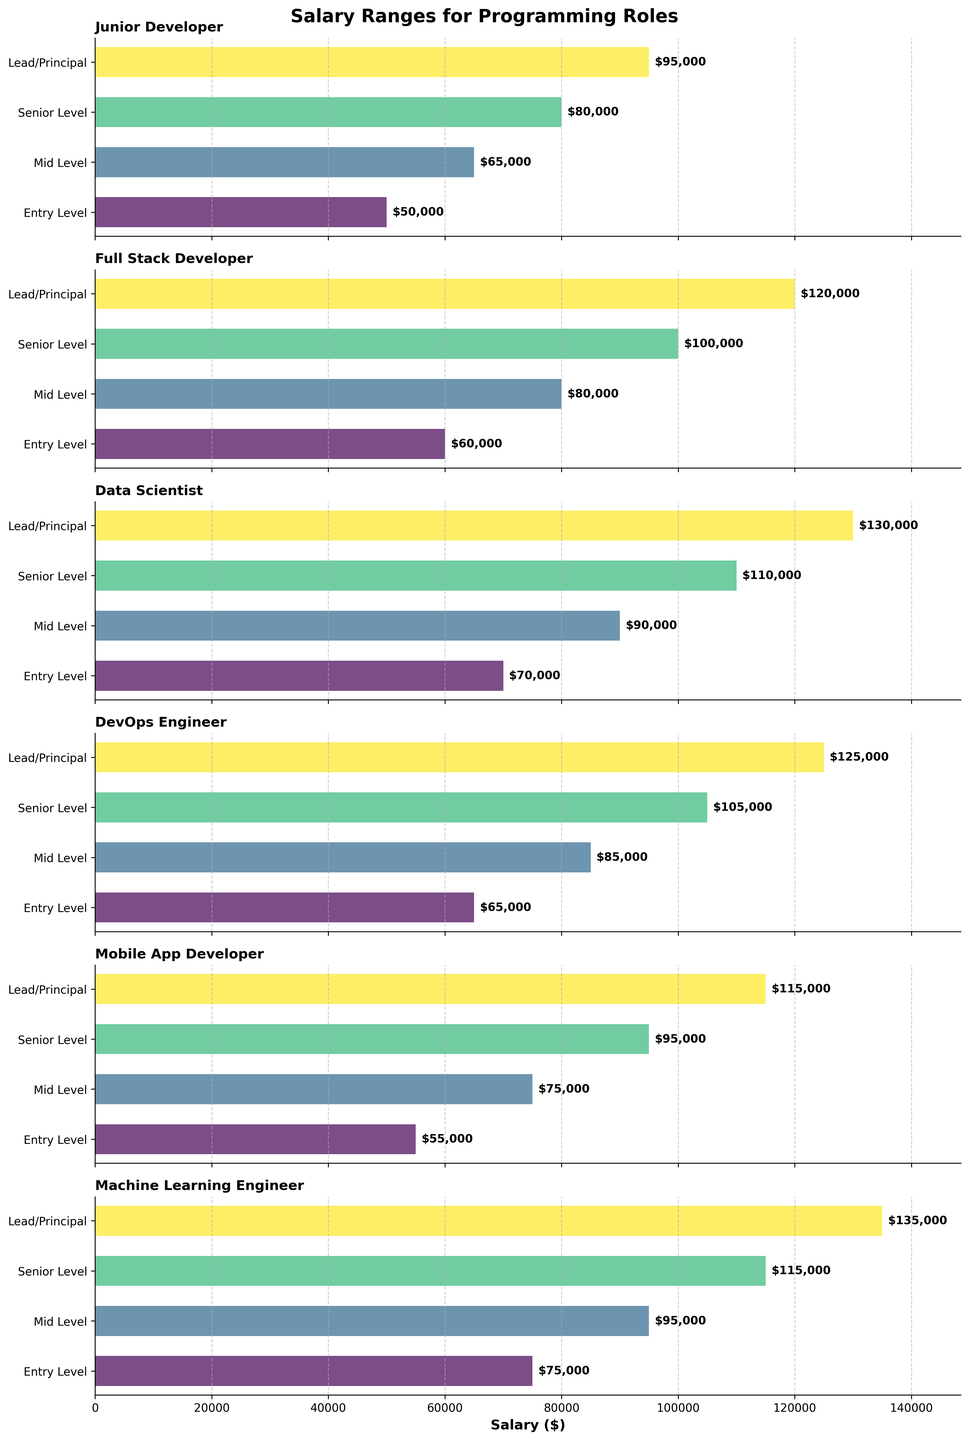What is the salary for an Entry Level Data Scientist? The salary for an Entry Level Data Scientist can be found by looking at the corresponding bar in the Data Scientist subplot and reading the value.
Answer: $70,000 Which role has the highest salary at the Senior Level? Compare the heights of the bars for the Senior Level across all subplots. The highest bar represents the highest salary.
Answer: Machine Learning Engineer How much more does a Lead/Principal Full Stack Developer make compared to a Mid Level Full Stack Developer? Subtract the salary of a Mid Level Full Stack Developer from that of a Lead/Principal Full Stack Developer.
Answer: $120,000 - $80,000 = $40,000 What's the difference in salary between a Lead/Principal DevOps Engineer and a Senior Level DevOps Engineer? Subtract the salary of a Senior Level DevOps Engineer from that of a Lead/Principal DevOps Engineer.
Answer: $125,000 - $105,000 = $20,000 Which role has the lowest salary at the Entry Level? Compare the heights of the bars for the Entry Level across all subplots. The lowest bar represents the lowest salary.
Answer: Junior Developer What is the average salary for a Senior Level Data Scientist and a Senior Level DevOps Engineer? Add the salaries of a Senior Level Data Scientist and a Senior Level DevOps Engineer, then divide by 2.
Answer: ($110,000 + $105,000) / 2 = $107,500 Is the salary range for a Mid Level Mobile App Developer closer to the Entry Level or Senior Level salary for the same role? Compare the salary for a Mid Level Mobile App Developer to the Entry Level and Senior Level salaries and see which it is closer to.
Answer: Closer to Senior Level Which role sees the most significant salary increase from Entry Level to Mid Level? Calculate the difference in salary from Entry Level to Mid Level for each role and identify the largest increase.
Answer: Data Scientist Considering Lead/Principal roles, which position has the second-lowest salary? Compare the salaries of all Lead/Principal roles and identify the second-lowest.
Answer: Mobile App Developer What's the range of salary (difference between the highest and lowest) for the Machine Learning Engineer role? Subtract the Entry Level salary from the Lead/Principal salary for the Machine Learning Engineer role.
Answer: $135,000 - $75,000 = $60,000 